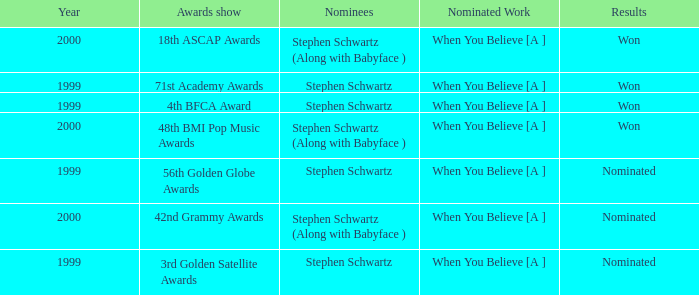What was the result in 2000? Won, Won, Nominated. 